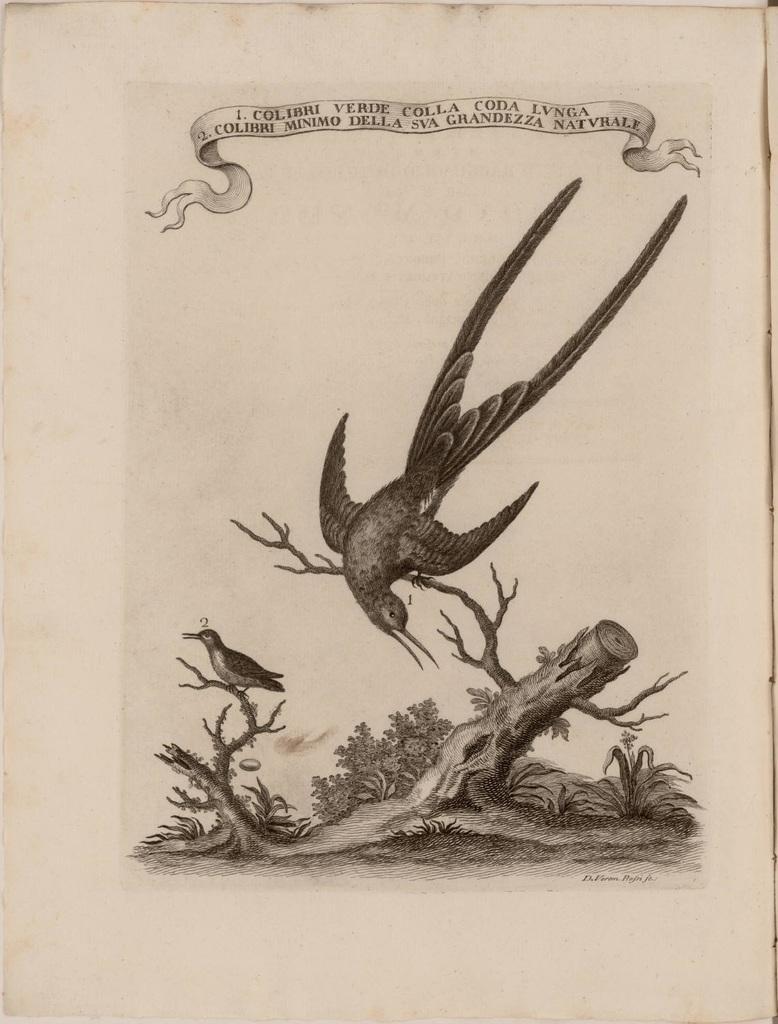Describe this image in one or two sentences. In this image, we can see birds on the dry stem. There is a text at the top of the image. 